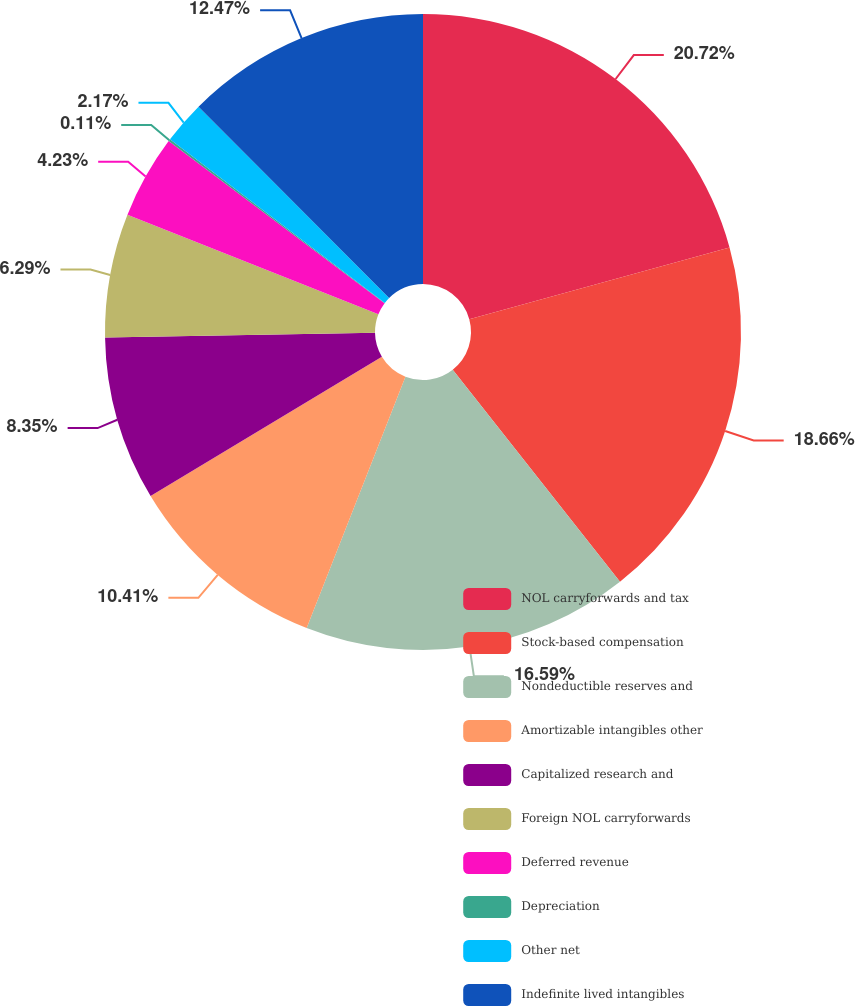Convert chart. <chart><loc_0><loc_0><loc_500><loc_500><pie_chart><fcel>NOL carryforwards and tax<fcel>Stock-based compensation<fcel>Nondeductible reserves and<fcel>Amortizable intangibles other<fcel>Capitalized research and<fcel>Foreign NOL carryforwards<fcel>Deferred revenue<fcel>Depreciation<fcel>Other net<fcel>Indefinite lived intangibles<nl><fcel>20.71%<fcel>18.65%<fcel>16.59%<fcel>10.41%<fcel>8.35%<fcel>6.29%<fcel>4.23%<fcel>0.11%<fcel>2.17%<fcel>12.47%<nl></chart> 